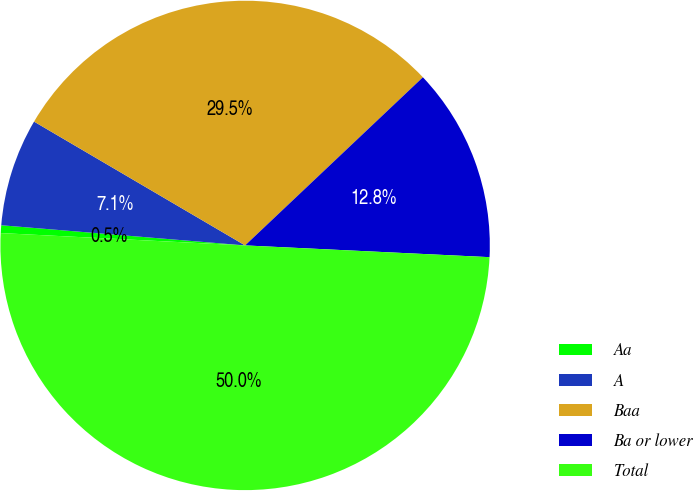Convert chart to OTSL. <chart><loc_0><loc_0><loc_500><loc_500><pie_chart><fcel>Aa<fcel>A<fcel>Baa<fcel>Ba or lower<fcel>Total<nl><fcel>0.51%<fcel>7.13%<fcel>29.5%<fcel>12.82%<fcel>50.04%<nl></chart> 